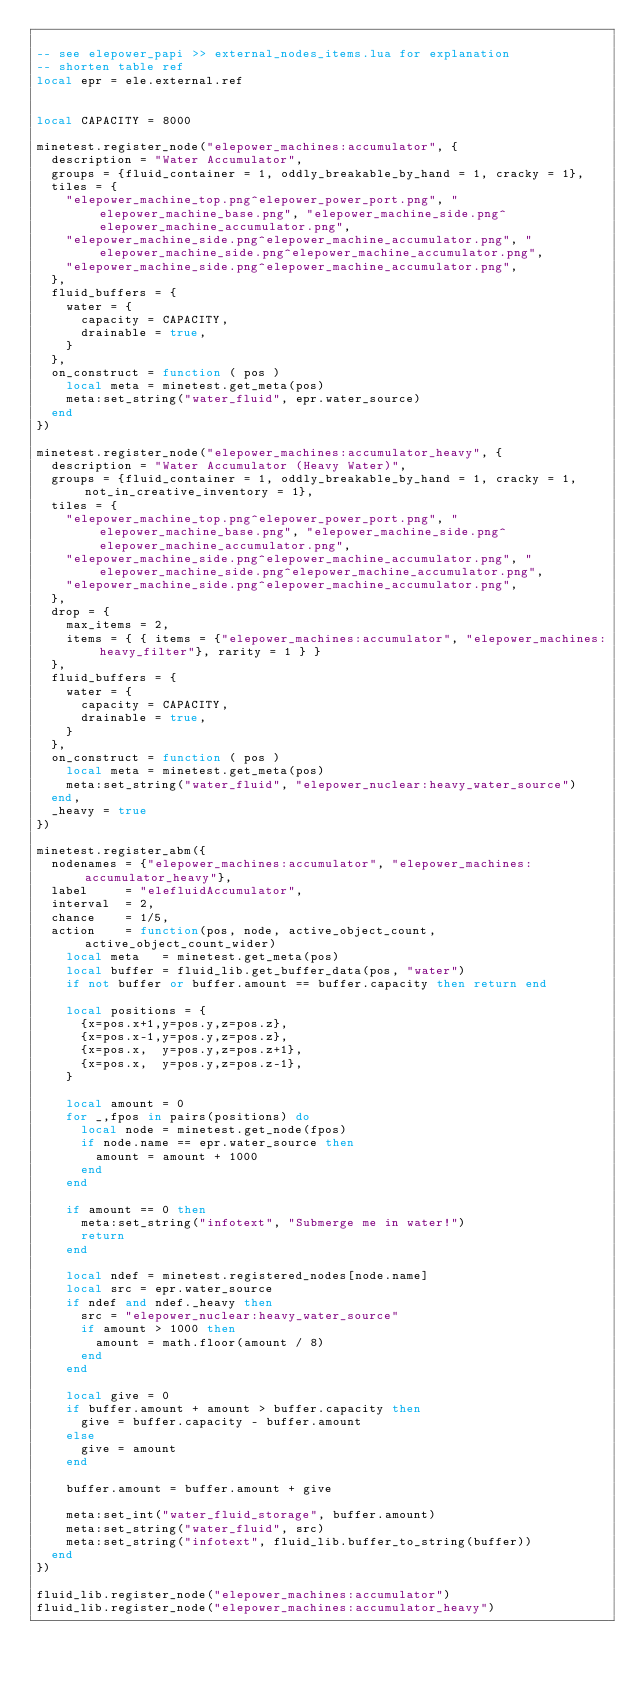Convert code to text. <code><loc_0><loc_0><loc_500><loc_500><_Lua_>
-- see elepower_papi >> external_nodes_items.lua for explanation
-- shorten table ref
local epr = ele.external.ref


local CAPACITY = 8000

minetest.register_node("elepower_machines:accumulator", {
	description = "Water Accumulator",
	groups = {fluid_container = 1, oddly_breakable_by_hand = 1, cracky = 1},
	tiles = {
		"elepower_machine_top.png^elepower_power_port.png", "elepower_machine_base.png", "elepower_machine_side.png^elepower_machine_accumulator.png",
		"elepower_machine_side.png^elepower_machine_accumulator.png", "elepower_machine_side.png^elepower_machine_accumulator.png",
		"elepower_machine_side.png^elepower_machine_accumulator.png",
	},
	fluid_buffers = {
		water = {
			capacity = CAPACITY,
			drainable = true,
		}
	},
	on_construct = function ( pos )
		local meta = minetest.get_meta(pos)
		meta:set_string("water_fluid", epr.water_source)
	end
})

minetest.register_node("elepower_machines:accumulator_heavy", {
	description = "Water Accumulator (Heavy Water)",
	groups = {fluid_container = 1, oddly_breakable_by_hand = 1, cracky = 1, not_in_creative_inventory = 1},
	tiles = {
		"elepower_machine_top.png^elepower_power_port.png", "elepower_machine_base.png", "elepower_machine_side.png^elepower_machine_accumulator.png",
		"elepower_machine_side.png^elepower_machine_accumulator.png", "elepower_machine_side.png^elepower_machine_accumulator.png",
		"elepower_machine_side.png^elepower_machine_accumulator.png",
	},
	drop = {
		max_items = 2,
		items = { { items = {"elepower_machines:accumulator", "elepower_machines:heavy_filter"}, rarity = 1 } }
	},
	fluid_buffers = {
		water = {
			capacity = CAPACITY,
			drainable = true,
		}
	},
	on_construct = function ( pos )
		local meta = minetest.get_meta(pos)
		meta:set_string("water_fluid", "elepower_nuclear:heavy_water_source")
	end,
	_heavy = true
})

minetest.register_abm({
	nodenames = {"elepower_machines:accumulator", "elepower_machines:accumulator_heavy"},
	label     = "elefluidAccumulator",
	interval  = 2,
	chance    = 1/5,
	action    = function(pos, node, active_object_count, active_object_count_wider)
		local meta   = minetest.get_meta(pos)
		local buffer = fluid_lib.get_buffer_data(pos, "water")
		if not buffer or buffer.amount == buffer.capacity then return end

		local positions = {
			{x=pos.x+1,y=pos.y,z=pos.z},
			{x=pos.x-1,y=pos.y,z=pos.z},
			{x=pos.x,  y=pos.y,z=pos.z+1},
			{x=pos.x,  y=pos.y,z=pos.z-1},
		}

		local amount = 0
		for _,fpos in pairs(positions) do
			local node = minetest.get_node(fpos)
			if node.name == epr.water_source then
				amount = amount + 1000
			end
		end

		if amount == 0 then
			meta:set_string("infotext", "Submerge me in water!")
			return
		end

		local ndef = minetest.registered_nodes[node.name]
		local src = epr.water_source
		if ndef and ndef._heavy then
			src = "elepower_nuclear:heavy_water_source"
			if amount > 1000 then
				amount = math.floor(amount / 8)
			end
		end

		local give = 0
		if buffer.amount + amount > buffer.capacity then
			give = buffer.capacity - buffer.amount
		else
			give = amount
		end

		buffer.amount = buffer.amount + give

		meta:set_int("water_fluid_storage", buffer.amount)
		meta:set_string("water_fluid", src)
		meta:set_string("infotext", fluid_lib.buffer_to_string(buffer))
	end
})

fluid_lib.register_node("elepower_machines:accumulator")
fluid_lib.register_node("elepower_machines:accumulator_heavy")
</code> 